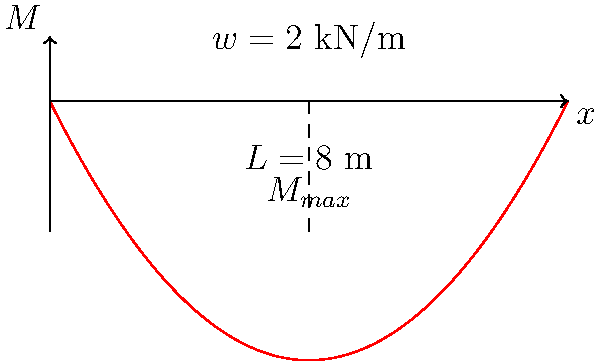As an undercover operative monitoring a retail space, you notice a suspicious beam supporting a heavy shelf. The beam is simply supported with a span of 8 meters and carries a uniformly distributed load of 2 kN/m. Based on the bending moment diagram shown, what is the maximum bending moment in the beam, and at what distance from the left support does it occur? To solve this problem, let's follow these steps:

1) For a simply supported beam with a uniformly distributed load, the bending moment diagram is parabolic.

2) The maximum bending moment occurs at the midspan of the beam.

3) The formula for the maximum bending moment in this case is:

   $$M_{max} = \frac{wL^2}{8}$$

   where $w$ is the uniformly distributed load and $L$ is the span length.

4) Given:
   $w = 2$ kN/m
   $L = 8$ m

5) Substituting these values:

   $$M_{max} = \frac{2 \cdot 8^2}{8} = \frac{128}{8} = 16$$ kN·m

6) The location of the maximum bending moment is at the midspan, which is:

   $$\frac{L}{2} = \frac{8}{2} = 4$$ m from either support

Therefore, the maximum bending moment is 16 kN·m and it occurs 4 m from the left support.
Answer: 16 kN·m at 4 m from left support 